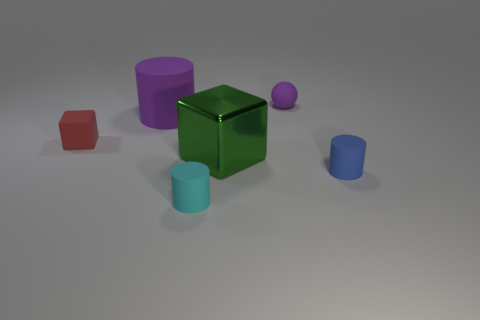Add 3 big red cylinders. How many objects exist? 9 Subtract all small blue cylinders. How many cylinders are left? 2 Subtract 2 cylinders. How many cylinders are left? 1 Subtract all red cylinders. How many blue blocks are left? 0 Subtract all green metal things. Subtract all small purple metal balls. How many objects are left? 5 Add 1 purple cylinders. How many purple cylinders are left? 2 Add 1 green metal objects. How many green metal objects exist? 2 Subtract all blue cylinders. How many cylinders are left? 2 Subtract 1 red blocks. How many objects are left? 5 Subtract all spheres. How many objects are left? 5 